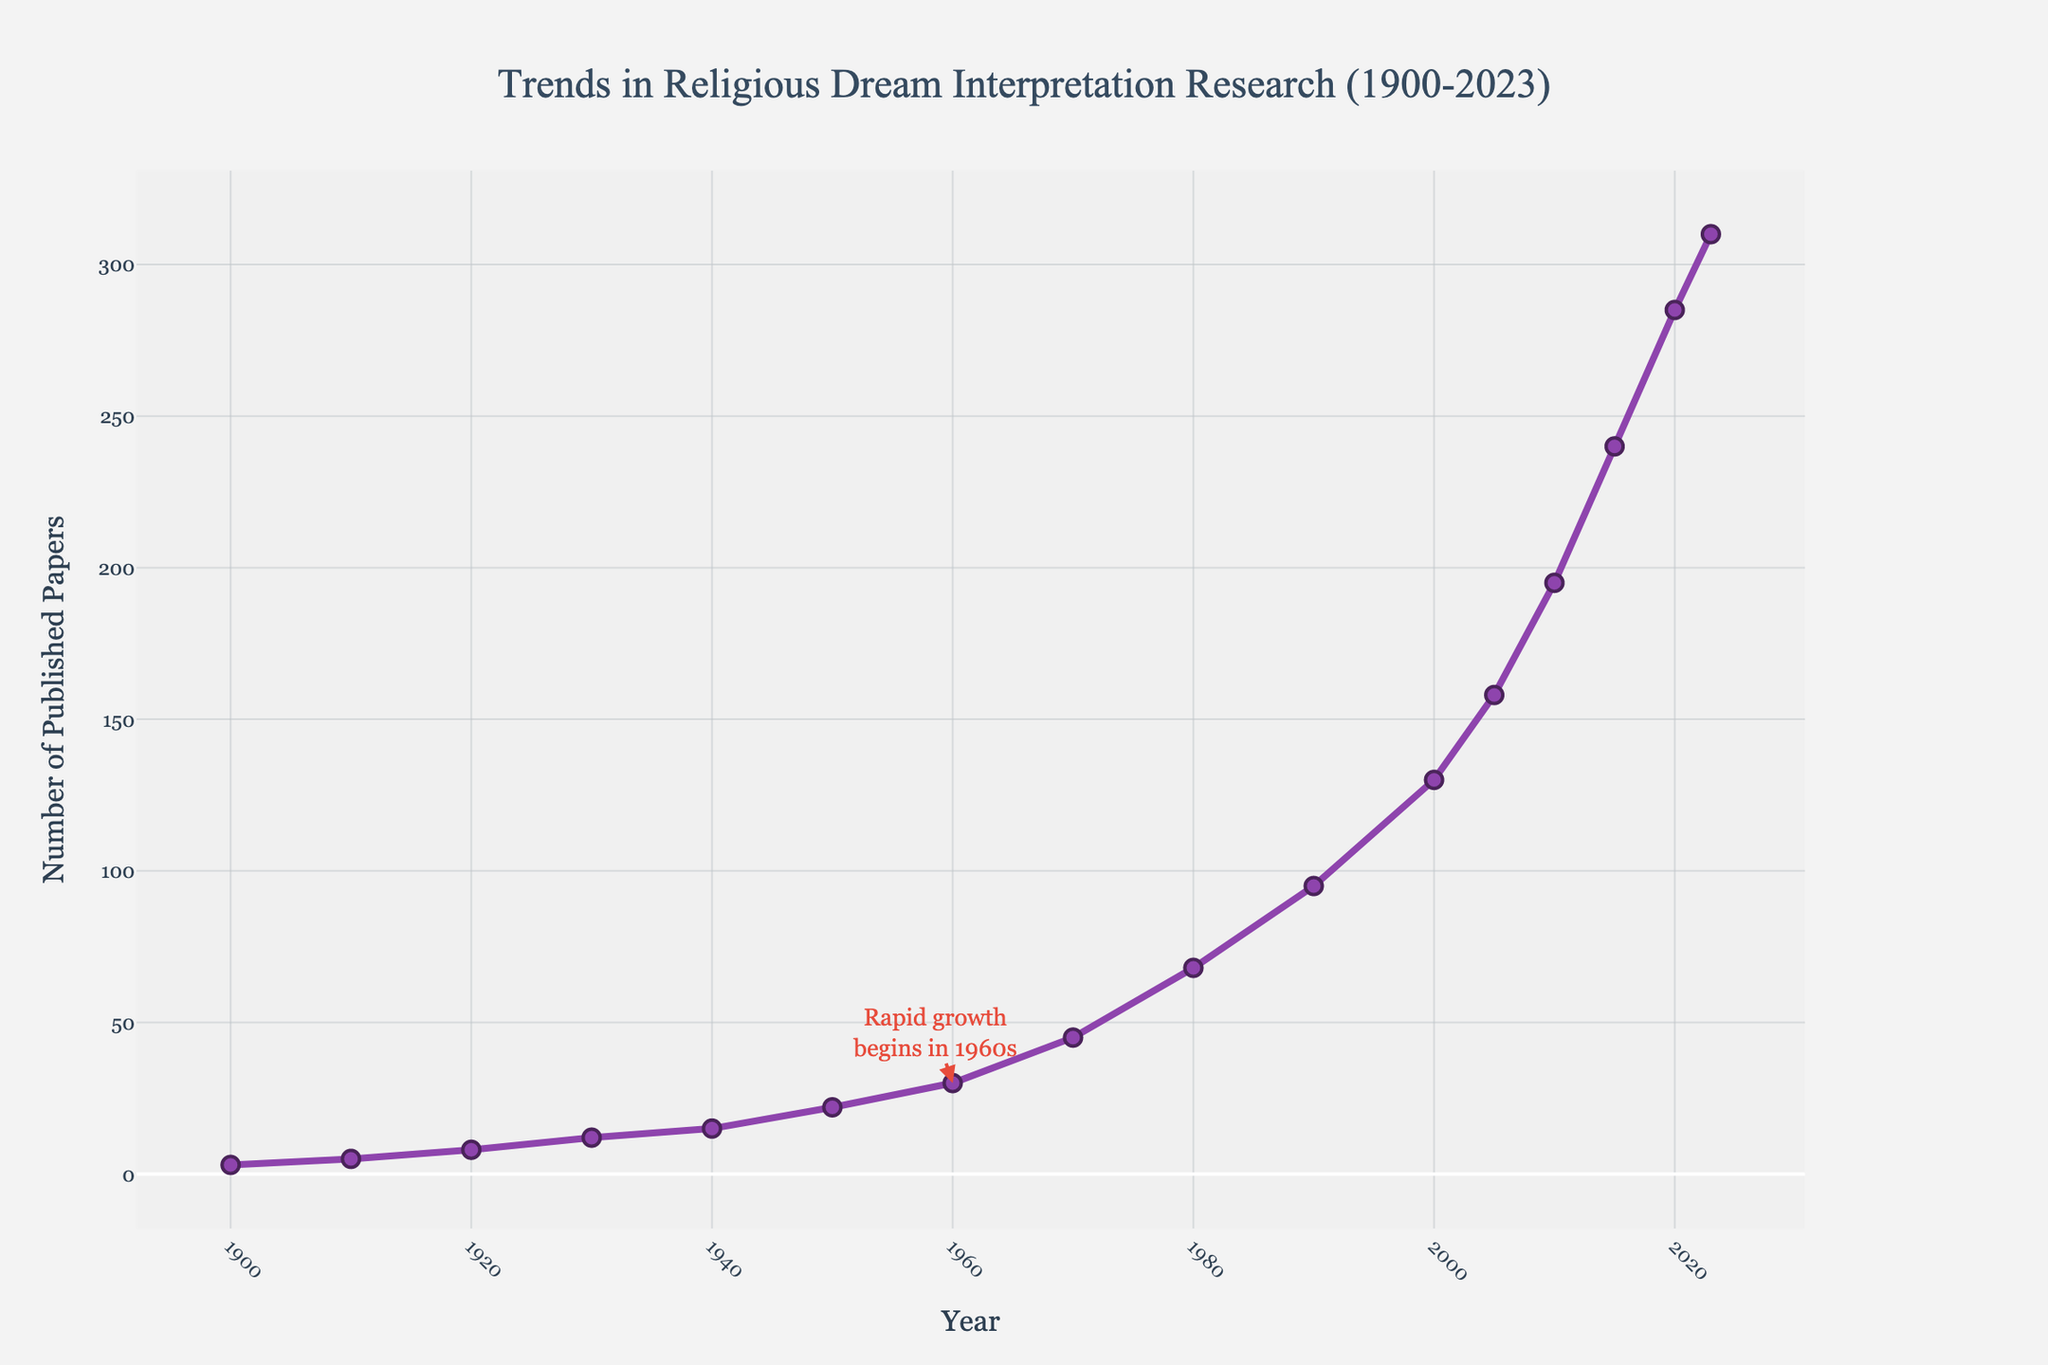What is the overall trend seen in the number of published papers on religious dream interpretation from 1900 to 2023? The number of published papers shows a clear increasing trend from 1900 to 2023. The plot illustrates that the number of papers gradually increases over time, with a notable rapid growth beginning around the 1960s.
Answer: Increasing trend In which decade did the most significant increase in the number of published papers occur? The most significant increase in the number of published papers appears to occur between 1960 and 1970. The line steeply rises from 30 papers in 1960 to 45 papers in 1970, indicating rapid growth.
Answer: 1960 to 1970 What is the total increase in the number of published papers from 2000 to 2023? In 2000, there are 130 papers published, and in 2023, there are 310 papers published. The total increase is the difference between these two values, which is 310 - 130.
Answer: 180 Which year marks the beginning of rapid growth in the number of papers, according to the annotation? The annotation on the figure indicates that rapid growth begins in the 1960s.
Answer: 1960s How many more academic papers were published in 2023 compared to 1980? In 2023, there are 310 papers published. In 1980, there are 68 papers published. The difference is 310 - 68.
Answer: 242 By how much did the number of papers increase between 1950 and 1960? In 1950, there are 22 papers published. In 1960, there are 30 papers published. The increase is calculated as 30 - 22.
Answer: 8 What is the average number of published papers per decade from 1900 to 2023? There are 16 different data points, representing each decade. Summing all the numbers of papers published from 1900 to 2023 is 3 + 5 + 8 + 12 + 15 + 22 + 30 + 45 + 68 + 95 + 130 + 158 + 195 + 240 + 285 + 310 = 1631. Dividing this sum by the number of decades (16) gives the average.
Answer: 102 During which decade did the number of published papers first exceed 100? The number of published papers first exceeds 100 in the 1990s, where it reaches a value of 95 and then increases rapidly.
Answer: 1990s Which year had exactly double the number of papers published compared to 1940? In 1940, there are 15 papers published. Double this number is 30. In 1960, the number of papers published is exactly 30.
Answer: 1960 How many more papers were published between 2015 and 2023 compared to between 2005 and 2015? The number of papers in 2015 is 240 and in 2023 is 310, so the increase from 2015 to 2023 is 310 - 240 = 70. From 2005 to 2015, the increase is 240 - 158 = 82. The difference between these two increases is 82 - 70.
Answer: 12 